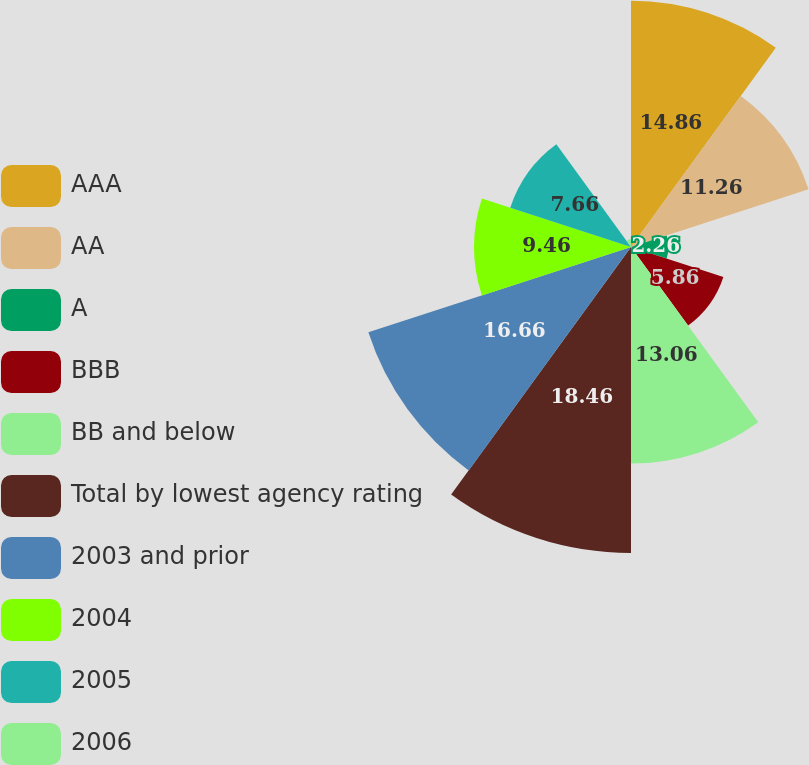Convert chart. <chart><loc_0><loc_0><loc_500><loc_500><pie_chart><fcel>AAA<fcel>AA<fcel>A<fcel>BBB<fcel>BB and below<fcel>Total by lowest agency rating<fcel>2003 and prior<fcel>2004<fcel>2005<fcel>2006<nl><fcel>14.86%<fcel>11.26%<fcel>2.26%<fcel>5.86%<fcel>13.06%<fcel>18.46%<fcel>16.66%<fcel>9.46%<fcel>7.66%<fcel>0.46%<nl></chart> 